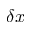Convert formula to latex. <formula><loc_0><loc_0><loc_500><loc_500>\delta x</formula> 